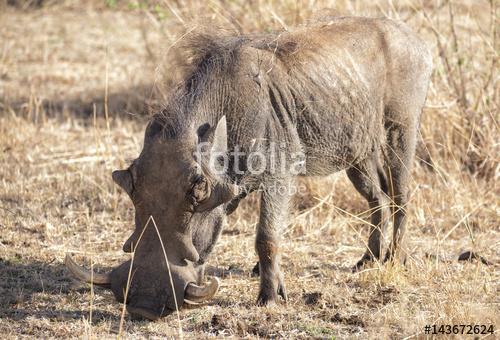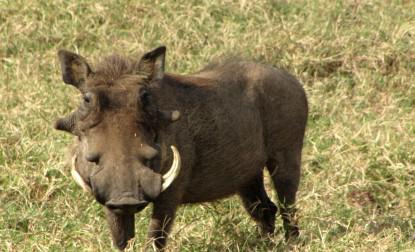The first image is the image on the left, the second image is the image on the right. Given the left and right images, does the statement "The hog on the right has it's mouth on the ground." hold true? Answer yes or no. No. 